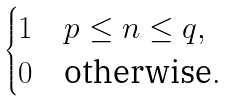<formula> <loc_0><loc_0><loc_500><loc_500>\begin{cases} 1 & p \leq n \leq q , \\ 0 & \text {otherwise} . \end{cases}</formula> 